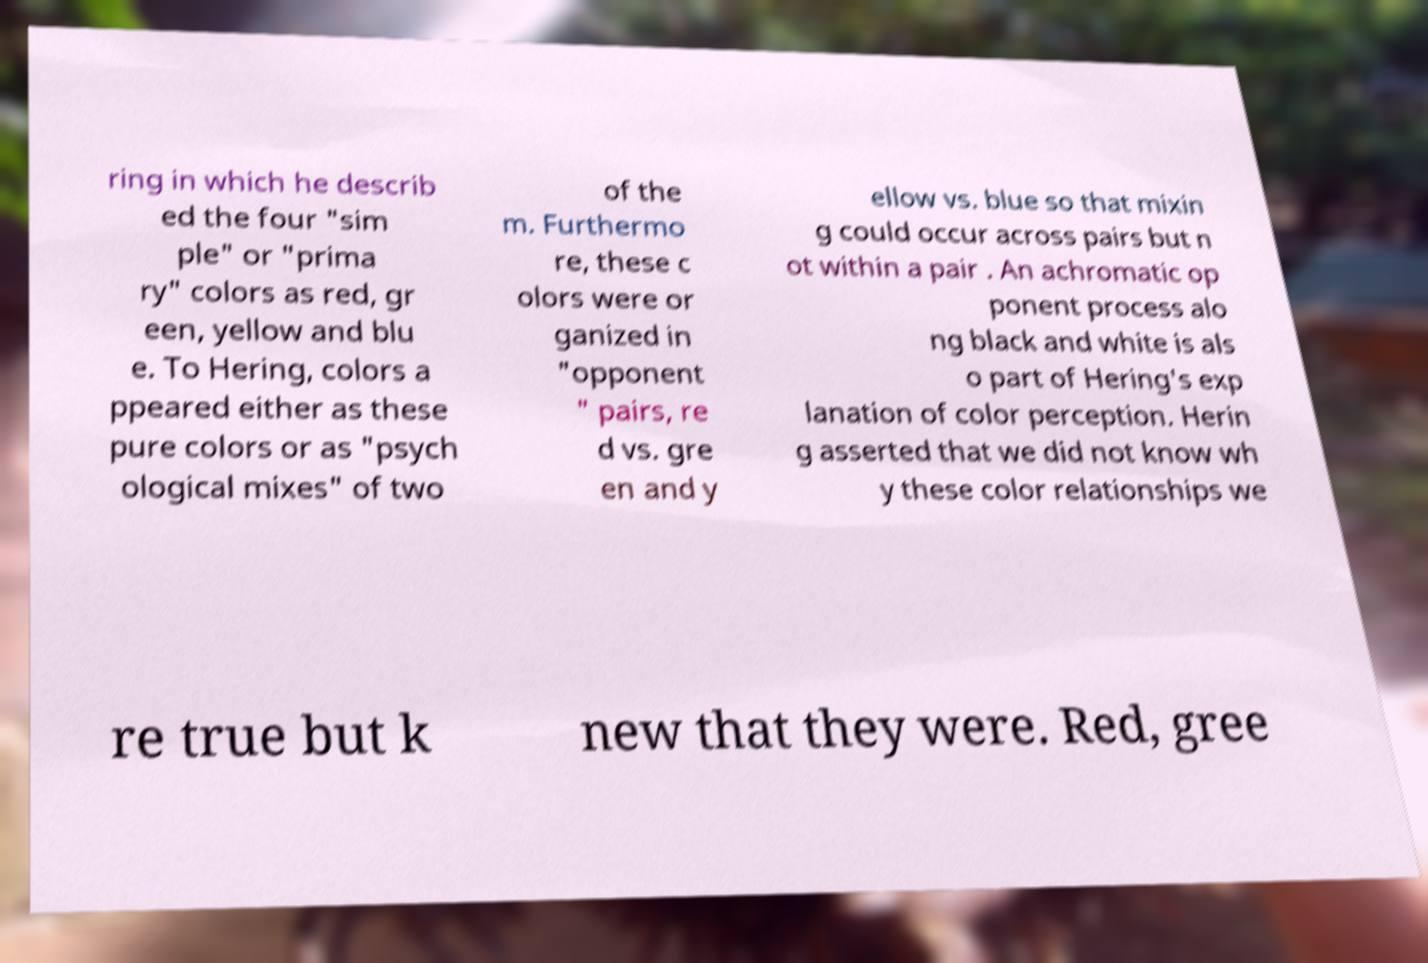Could you extract and type out the text from this image? ring in which he describ ed the four "sim ple" or "prima ry" colors as red, gr een, yellow and blu e. To Hering, colors a ppeared either as these pure colors or as "psych ological mixes" of two of the m. Furthermo re, these c olors were or ganized in "opponent " pairs, re d vs. gre en and y ellow vs. blue so that mixin g could occur across pairs but n ot within a pair . An achromatic op ponent process alo ng black and white is als o part of Hering's exp lanation of color perception. Herin g asserted that we did not know wh y these color relationships we re true but k new that they were. Red, gree 